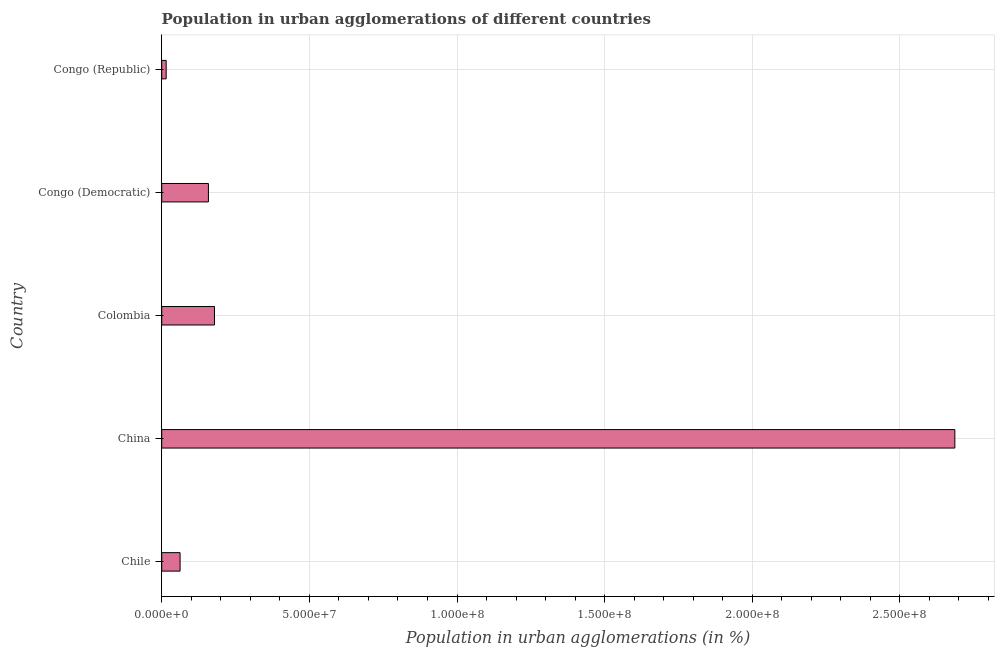Does the graph contain any zero values?
Offer a terse response. No. Does the graph contain grids?
Ensure brevity in your answer.  Yes. What is the title of the graph?
Provide a succinct answer. Population in urban agglomerations of different countries. What is the label or title of the X-axis?
Keep it short and to the point. Population in urban agglomerations (in %). What is the label or title of the Y-axis?
Ensure brevity in your answer.  Country. What is the population in urban agglomerations in Congo (Republic)?
Keep it short and to the point. 1.51e+06. Across all countries, what is the maximum population in urban agglomerations?
Offer a very short reply. 2.69e+08. Across all countries, what is the minimum population in urban agglomerations?
Your response must be concise. 1.51e+06. In which country was the population in urban agglomerations maximum?
Give a very brief answer. China. In which country was the population in urban agglomerations minimum?
Provide a succinct answer. Congo (Republic). What is the sum of the population in urban agglomerations?
Make the answer very short. 3.10e+08. What is the difference between the population in urban agglomerations in China and Congo (Republic)?
Make the answer very short. 2.67e+08. What is the average population in urban agglomerations per country?
Your answer should be compact. 6.20e+07. What is the median population in urban agglomerations?
Your answer should be very brief. 1.58e+07. What is the ratio of the population in urban agglomerations in Chile to that in Congo (Republic)?
Make the answer very short. 4.12. Is the difference between the population in urban agglomerations in Chile and Colombia greater than the difference between any two countries?
Your response must be concise. No. What is the difference between the highest and the second highest population in urban agglomerations?
Your answer should be compact. 2.51e+08. What is the difference between the highest and the lowest population in urban agglomerations?
Offer a very short reply. 2.67e+08. In how many countries, is the population in urban agglomerations greater than the average population in urban agglomerations taken over all countries?
Your response must be concise. 1. How many bars are there?
Offer a terse response. 5. Are all the bars in the graph horizontal?
Keep it short and to the point. Yes. Are the values on the major ticks of X-axis written in scientific E-notation?
Your response must be concise. Yes. What is the Population in urban agglomerations (in %) of Chile?
Provide a succinct answer. 6.22e+06. What is the Population in urban agglomerations (in %) of China?
Provide a short and direct response. 2.69e+08. What is the Population in urban agglomerations (in %) of Colombia?
Keep it short and to the point. 1.79e+07. What is the Population in urban agglomerations (in %) of Congo (Democratic)?
Provide a short and direct response. 1.58e+07. What is the Population in urban agglomerations (in %) in Congo (Republic)?
Your answer should be compact. 1.51e+06. What is the difference between the Population in urban agglomerations (in %) in Chile and China?
Your answer should be very brief. -2.62e+08. What is the difference between the Population in urban agglomerations (in %) in Chile and Colombia?
Make the answer very short. -1.17e+07. What is the difference between the Population in urban agglomerations (in %) in Chile and Congo (Democratic)?
Offer a very short reply. -9.60e+06. What is the difference between the Population in urban agglomerations (in %) in Chile and Congo (Republic)?
Your response must be concise. 4.71e+06. What is the difference between the Population in urban agglomerations (in %) in China and Colombia?
Your response must be concise. 2.51e+08. What is the difference between the Population in urban agglomerations (in %) in China and Congo (Democratic)?
Offer a terse response. 2.53e+08. What is the difference between the Population in urban agglomerations (in %) in China and Congo (Republic)?
Provide a short and direct response. 2.67e+08. What is the difference between the Population in urban agglomerations (in %) in Colombia and Congo (Democratic)?
Offer a very short reply. 2.05e+06. What is the difference between the Population in urban agglomerations (in %) in Colombia and Congo (Republic)?
Your answer should be very brief. 1.64e+07. What is the difference between the Population in urban agglomerations (in %) in Congo (Democratic) and Congo (Republic)?
Your response must be concise. 1.43e+07. What is the ratio of the Population in urban agglomerations (in %) in Chile to that in China?
Your answer should be very brief. 0.02. What is the ratio of the Population in urban agglomerations (in %) in Chile to that in Colombia?
Provide a succinct answer. 0.35. What is the ratio of the Population in urban agglomerations (in %) in Chile to that in Congo (Democratic)?
Your answer should be very brief. 0.39. What is the ratio of the Population in urban agglomerations (in %) in Chile to that in Congo (Republic)?
Offer a very short reply. 4.12. What is the ratio of the Population in urban agglomerations (in %) in China to that in Colombia?
Offer a very short reply. 15.03. What is the ratio of the Population in urban agglomerations (in %) in China to that in Congo (Democratic)?
Offer a very short reply. 16.98. What is the ratio of the Population in urban agglomerations (in %) in China to that in Congo (Republic)?
Your answer should be compact. 177.97. What is the ratio of the Population in urban agglomerations (in %) in Colombia to that in Congo (Democratic)?
Offer a very short reply. 1.13. What is the ratio of the Population in urban agglomerations (in %) in Colombia to that in Congo (Republic)?
Your answer should be compact. 11.84. What is the ratio of the Population in urban agglomerations (in %) in Congo (Democratic) to that in Congo (Republic)?
Keep it short and to the point. 10.48. 